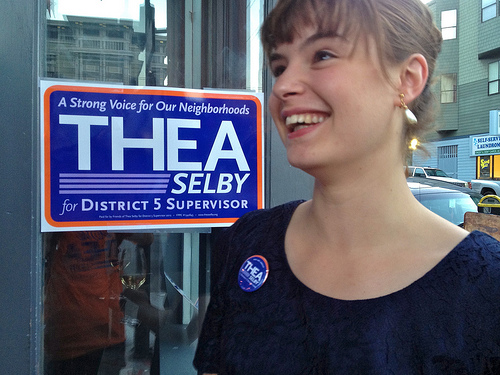<image>
Is there a sign above the button? Yes. The sign is positioned above the button in the vertical space, higher up in the scene. 